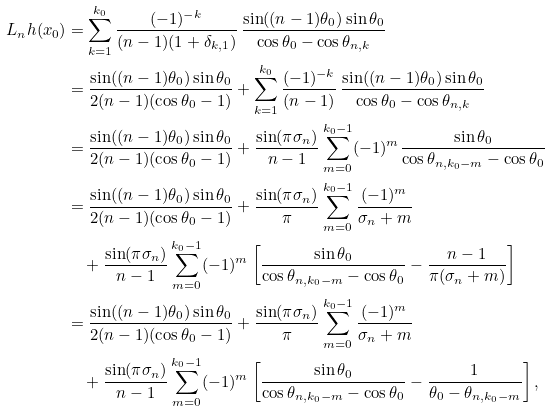<formula> <loc_0><loc_0><loc_500><loc_500>L _ { n } h ( x _ { 0 } ) & = \sum ^ { k _ { 0 } } _ { k = 1 } \frac { ( - 1 ) ^ { - k } } { ( n - 1 ) ( 1 + \delta _ { k , 1 } ) } \, \frac { \sin ( ( n - 1 ) \theta _ { 0 } ) \sin \theta _ { 0 } } { \cos \theta _ { 0 } - \cos \theta _ { n , k } } \\ & = \frac { \sin ( ( n - 1 ) \theta _ { 0 } ) \sin \theta _ { 0 } } { 2 ( n - 1 ) ( \cos \theta _ { 0 } - 1 ) } + \sum ^ { k _ { 0 } } _ { k = 1 } \frac { ( - 1 ) ^ { - k } } { ( n - 1 ) } \, \frac { \sin ( ( n - 1 ) \theta _ { 0 } ) \sin \theta _ { 0 } } { \cos \theta _ { 0 } - \cos \theta _ { n , k } } \\ & = \frac { \sin ( ( n - 1 ) \theta _ { 0 } ) \sin \theta _ { 0 } } { 2 ( n - 1 ) ( \cos \theta _ { 0 } - 1 ) } + \frac { \sin ( \pi \sigma _ { n } ) } { n - 1 } \sum ^ { k _ { 0 } - 1 } _ { m = 0 } ( - 1 ) ^ { m } \frac { \sin \theta _ { 0 } } { \cos \theta _ { n , k _ { 0 } - m } - \cos \theta _ { 0 } } \\ & = \frac { \sin ( ( n - 1 ) \theta _ { 0 } ) \sin \theta _ { 0 } } { 2 ( n - 1 ) ( \cos \theta _ { 0 } - 1 ) } + \frac { \sin ( \pi \sigma _ { n } ) } { \pi } \sum ^ { k _ { 0 } - 1 } _ { m = 0 } \frac { ( - 1 ) ^ { m } } { \sigma _ { n } + m } \\ & \quad + \frac { \sin ( \pi \sigma _ { n } ) } { n - 1 } \sum ^ { k _ { 0 } - 1 } _ { m = 0 } ( - 1 ) ^ { m } \left [ \frac { \sin \theta _ { 0 } } { \cos \theta _ { n , k _ { 0 } - m } - \cos \theta _ { 0 } } - \frac { n - 1 } { \pi ( \sigma _ { n } + m ) } \right ] \\ & = \frac { \sin ( ( n - 1 ) \theta _ { 0 } ) \sin \theta _ { 0 } } { 2 ( n - 1 ) ( \cos \theta _ { 0 } - 1 ) } + \frac { \sin ( \pi \sigma _ { n } ) } { \pi } \sum ^ { k _ { 0 } - 1 } _ { m = 0 } \frac { ( - 1 ) ^ { m } } { \sigma _ { n } + m } \\ & \quad + \frac { \sin ( \pi \sigma _ { n } ) } { n - 1 } \sum ^ { k _ { 0 } - 1 } _ { m = 0 } ( - 1 ) ^ { m } \left [ \frac { \sin \theta _ { 0 } } { \cos \theta _ { n , k _ { 0 } - m } - \cos \theta _ { 0 } } - \frac { 1 } { \theta _ { 0 } - \theta _ { n , k _ { 0 } - m } } \right ] ,</formula> 